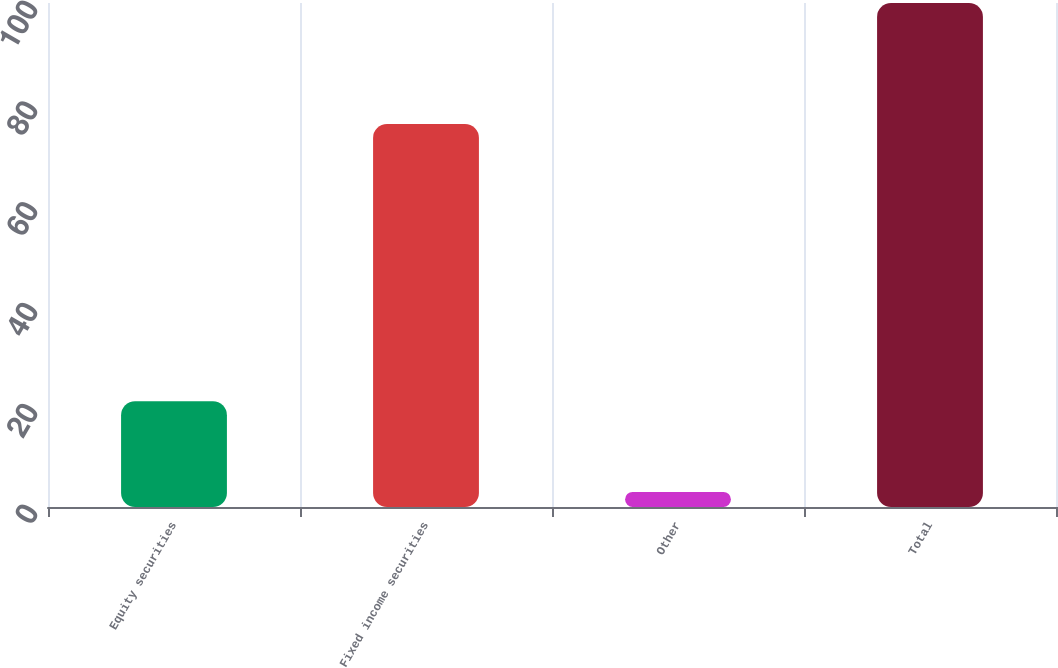Convert chart to OTSL. <chart><loc_0><loc_0><loc_500><loc_500><bar_chart><fcel>Equity securities<fcel>Fixed income securities<fcel>Other<fcel>Total<nl><fcel>21<fcel>76<fcel>3<fcel>100<nl></chart> 